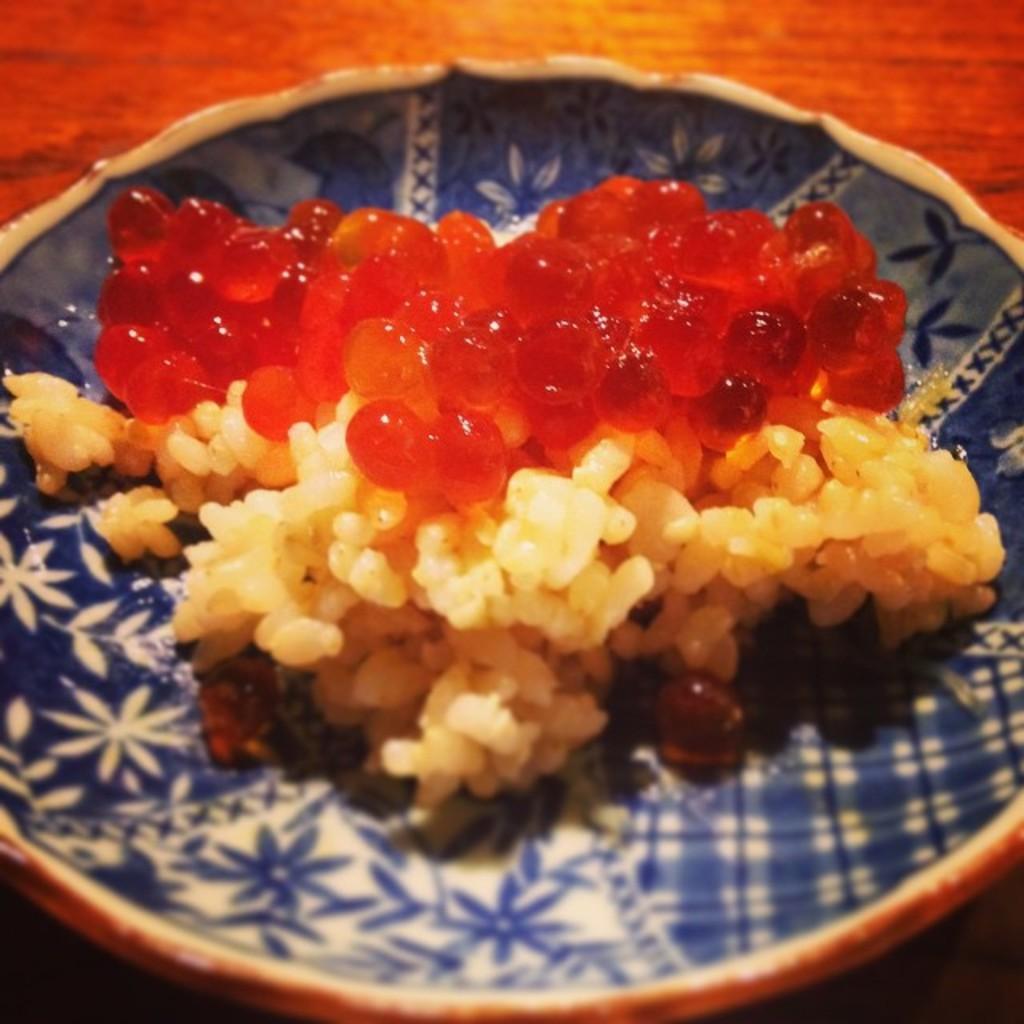Please provide a concise description of this image. In this picture we can see a plate in the front, there is some food present in this plate, at the bottom there is a wooden surface. 